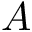<formula> <loc_0><loc_0><loc_500><loc_500>A</formula> 